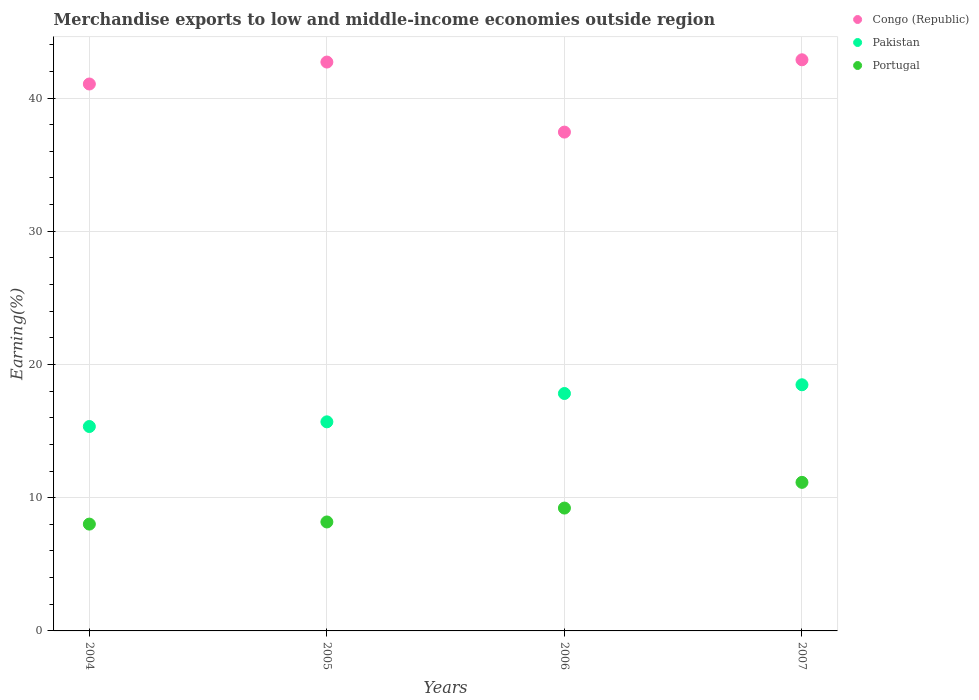How many different coloured dotlines are there?
Offer a terse response. 3. Is the number of dotlines equal to the number of legend labels?
Make the answer very short. Yes. What is the percentage of amount earned from merchandise exports in Portugal in 2007?
Provide a short and direct response. 11.15. Across all years, what is the maximum percentage of amount earned from merchandise exports in Pakistan?
Ensure brevity in your answer.  18.48. Across all years, what is the minimum percentage of amount earned from merchandise exports in Portugal?
Provide a succinct answer. 8.02. In which year was the percentage of amount earned from merchandise exports in Portugal minimum?
Make the answer very short. 2004. What is the total percentage of amount earned from merchandise exports in Portugal in the graph?
Give a very brief answer. 36.57. What is the difference between the percentage of amount earned from merchandise exports in Congo (Republic) in 2005 and that in 2006?
Provide a succinct answer. 5.26. What is the difference between the percentage of amount earned from merchandise exports in Portugal in 2005 and the percentage of amount earned from merchandise exports in Congo (Republic) in 2007?
Ensure brevity in your answer.  -34.69. What is the average percentage of amount earned from merchandise exports in Pakistan per year?
Provide a short and direct response. 16.83. In the year 2005, what is the difference between the percentage of amount earned from merchandise exports in Portugal and percentage of amount earned from merchandise exports in Pakistan?
Your response must be concise. -7.52. What is the ratio of the percentage of amount earned from merchandise exports in Portugal in 2004 to that in 2007?
Make the answer very short. 0.72. Is the percentage of amount earned from merchandise exports in Portugal in 2005 less than that in 2006?
Your answer should be compact. Yes. What is the difference between the highest and the second highest percentage of amount earned from merchandise exports in Congo (Republic)?
Offer a very short reply. 0.17. What is the difference between the highest and the lowest percentage of amount earned from merchandise exports in Congo (Republic)?
Provide a short and direct response. 5.43. In how many years, is the percentage of amount earned from merchandise exports in Portugal greater than the average percentage of amount earned from merchandise exports in Portugal taken over all years?
Your answer should be very brief. 2. Does the percentage of amount earned from merchandise exports in Portugal monotonically increase over the years?
Provide a short and direct response. Yes. How many years are there in the graph?
Make the answer very short. 4. What is the difference between two consecutive major ticks on the Y-axis?
Make the answer very short. 10. Are the values on the major ticks of Y-axis written in scientific E-notation?
Give a very brief answer. No. Does the graph contain any zero values?
Your response must be concise. No. How many legend labels are there?
Make the answer very short. 3. What is the title of the graph?
Your answer should be very brief. Merchandise exports to low and middle-income economies outside region. What is the label or title of the Y-axis?
Provide a short and direct response. Earning(%). What is the Earning(%) of Congo (Republic) in 2004?
Ensure brevity in your answer.  41.05. What is the Earning(%) of Pakistan in 2004?
Make the answer very short. 15.34. What is the Earning(%) of Portugal in 2004?
Keep it short and to the point. 8.02. What is the Earning(%) in Congo (Republic) in 2005?
Your response must be concise. 42.7. What is the Earning(%) of Pakistan in 2005?
Give a very brief answer. 15.69. What is the Earning(%) of Portugal in 2005?
Offer a very short reply. 8.18. What is the Earning(%) in Congo (Republic) in 2006?
Offer a very short reply. 37.44. What is the Earning(%) of Pakistan in 2006?
Keep it short and to the point. 17.82. What is the Earning(%) of Portugal in 2006?
Provide a succinct answer. 9.22. What is the Earning(%) in Congo (Republic) in 2007?
Your answer should be compact. 42.87. What is the Earning(%) in Pakistan in 2007?
Give a very brief answer. 18.48. What is the Earning(%) of Portugal in 2007?
Ensure brevity in your answer.  11.15. Across all years, what is the maximum Earning(%) in Congo (Republic)?
Your response must be concise. 42.87. Across all years, what is the maximum Earning(%) in Pakistan?
Give a very brief answer. 18.48. Across all years, what is the maximum Earning(%) of Portugal?
Provide a short and direct response. 11.15. Across all years, what is the minimum Earning(%) of Congo (Republic)?
Your response must be concise. 37.44. Across all years, what is the minimum Earning(%) in Pakistan?
Provide a short and direct response. 15.34. Across all years, what is the minimum Earning(%) of Portugal?
Offer a very short reply. 8.02. What is the total Earning(%) of Congo (Republic) in the graph?
Offer a very short reply. 164.07. What is the total Earning(%) of Pakistan in the graph?
Your answer should be compact. 67.34. What is the total Earning(%) of Portugal in the graph?
Provide a succinct answer. 36.57. What is the difference between the Earning(%) of Congo (Republic) in 2004 and that in 2005?
Your answer should be compact. -1.65. What is the difference between the Earning(%) in Pakistan in 2004 and that in 2005?
Your answer should be compact. -0.35. What is the difference between the Earning(%) in Portugal in 2004 and that in 2005?
Your response must be concise. -0.16. What is the difference between the Earning(%) of Congo (Republic) in 2004 and that in 2006?
Your response must be concise. 3.61. What is the difference between the Earning(%) of Pakistan in 2004 and that in 2006?
Give a very brief answer. -2.48. What is the difference between the Earning(%) in Portugal in 2004 and that in 2006?
Provide a short and direct response. -1.2. What is the difference between the Earning(%) in Congo (Republic) in 2004 and that in 2007?
Offer a very short reply. -1.82. What is the difference between the Earning(%) in Pakistan in 2004 and that in 2007?
Make the answer very short. -3.13. What is the difference between the Earning(%) of Portugal in 2004 and that in 2007?
Provide a succinct answer. -3.13. What is the difference between the Earning(%) of Congo (Republic) in 2005 and that in 2006?
Keep it short and to the point. 5.26. What is the difference between the Earning(%) of Pakistan in 2005 and that in 2006?
Your answer should be very brief. -2.13. What is the difference between the Earning(%) in Portugal in 2005 and that in 2006?
Your answer should be compact. -1.04. What is the difference between the Earning(%) of Congo (Republic) in 2005 and that in 2007?
Provide a succinct answer. -0.17. What is the difference between the Earning(%) of Pakistan in 2005 and that in 2007?
Your response must be concise. -2.78. What is the difference between the Earning(%) of Portugal in 2005 and that in 2007?
Your answer should be compact. -2.97. What is the difference between the Earning(%) in Congo (Republic) in 2006 and that in 2007?
Ensure brevity in your answer.  -5.43. What is the difference between the Earning(%) in Pakistan in 2006 and that in 2007?
Ensure brevity in your answer.  -0.66. What is the difference between the Earning(%) of Portugal in 2006 and that in 2007?
Your answer should be very brief. -1.93. What is the difference between the Earning(%) in Congo (Republic) in 2004 and the Earning(%) in Pakistan in 2005?
Make the answer very short. 25.36. What is the difference between the Earning(%) of Congo (Republic) in 2004 and the Earning(%) of Portugal in 2005?
Keep it short and to the point. 32.88. What is the difference between the Earning(%) of Pakistan in 2004 and the Earning(%) of Portugal in 2005?
Your response must be concise. 7.17. What is the difference between the Earning(%) in Congo (Republic) in 2004 and the Earning(%) in Pakistan in 2006?
Ensure brevity in your answer.  23.23. What is the difference between the Earning(%) in Congo (Republic) in 2004 and the Earning(%) in Portugal in 2006?
Provide a succinct answer. 31.83. What is the difference between the Earning(%) of Pakistan in 2004 and the Earning(%) of Portugal in 2006?
Your answer should be compact. 6.12. What is the difference between the Earning(%) in Congo (Republic) in 2004 and the Earning(%) in Pakistan in 2007?
Offer a very short reply. 22.58. What is the difference between the Earning(%) in Congo (Republic) in 2004 and the Earning(%) in Portugal in 2007?
Your response must be concise. 29.9. What is the difference between the Earning(%) of Pakistan in 2004 and the Earning(%) of Portugal in 2007?
Give a very brief answer. 4.19. What is the difference between the Earning(%) of Congo (Republic) in 2005 and the Earning(%) of Pakistan in 2006?
Provide a succinct answer. 24.88. What is the difference between the Earning(%) in Congo (Republic) in 2005 and the Earning(%) in Portugal in 2006?
Keep it short and to the point. 33.48. What is the difference between the Earning(%) in Pakistan in 2005 and the Earning(%) in Portugal in 2006?
Provide a short and direct response. 6.47. What is the difference between the Earning(%) of Congo (Republic) in 2005 and the Earning(%) of Pakistan in 2007?
Offer a very short reply. 24.22. What is the difference between the Earning(%) of Congo (Republic) in 2005 and the Earning(%) of Portugal in 2007?
Give a very brief answer. 31.55. What is the difference between the Earning(%) in Pakistan in 2005 and the Earning(%) in Portugal in 2007?
Give a very brief answer. 4.54. What is the difference between the Earning(%) in Congo (Republic) in 2006 and the Earning(%) in Pakistan in 2007?
Your response must be concise. 18.97. What is the difference between the Earning(%) in Congo (Republic) in 2006 and the Earning(%) in Portugal in 2007?
Give a very brief answer. 26.29. What is the difference between the Earning(%) in Pakistan in 2006 and the Earning(%) in Portugal in 2007?
Your answer should be compact. 6.67. What is the average Earning(%) in Congo (Republic) per year?
Offer a very short reply. 41.02. What is the average Earning(%) of Pakistan per year?
Provide a short and direct response. 16.83. What is the average Earning(%) of Portugal per year?
Give a very brief answer. 9.14. In the year 2004, what is the difference between the Earning(%) in Congo (Republic) and Earning(%) in Pakistan?
Offer a very short reply. 25.71. In the year 2004, what is the difference between the Earning(%) in Congo (Republic) and Earning(%) in Portugal?
Give a very brief answer. 33.04. In the year 2004, what is the difference between the Earning(%) in Pakistan and Earning(%) in Portugal?
Your answer should be very brief. 7.33. In the year 2005, what is the difference between the Earning(%) in Congo (Republic) and Earning(%) in Pakistan?
Offer a very short reply. 27.01. In the year 2005, what is the difference between the Earning(%) in Congo (Republic) and Earning(%) in Portugal?
Offer a terse response. 34.52. In the year 2005, what is the difference between the Earning(%) of Pakistan and Earning(%) of Portugal?
Your answer should be very brief. 7.52. In the year 2006, what is the difference between the Earning(%) of Congo (Republic) and Earning(%) of Pakistan?
Provide a short and direct response. 19.62. In the year 2006, what is the difference between the Earning(%) of Congo (Republic) and Earning(%) of Portugal?
Ensure brevity in your answer.  28.22. In the year 2006, what is the difference between the Earning(%) in Pakistan and Earning(%) in Portugal?
Your answer should be compact. 8.6. In the year 2007, what is the difference between the Earning(%) of Congo (Republic) and Earning(%) of Pakistan?
Your answer should be compact. 24.39. In the year 2007, what is the difference between the Earning(%) of Congo (Republic) and Earning(%) of Portugal?
Provide a succinct answer. 31.72. In the year 2007, what is the difference between the Earning(%) in Pakistan and Earning(%) in Portugal?
Provide a succinct answer. 7.33. What is the ratio of the Earning(%) of Congo (Republic) in 2004 to that in 2005?
Keep it short and to the point. 0.96. What is the ratio of the Earning(%) in Pakistan in 2004 to that in 2005?
Ensure brevity in your answer.  0.98. What is the ratio of the Earning(%) of Portugal in 2004 to that in 2005?
Give a very brief answer. 0.98. What is the ratio of the Earning(%) in Congo (Republic) in 2004 to that in 2006?
Make the answer very short. 1.1. What is the ratio of the Earning(%) in Pakistan in 2004 to that in 2006?
Your response must be concise. 0.86. What is the ratio of the Earning(%) of Portugal in 2004 to that in 2006?
Keep it short and to the point. 0.87. What is the ratio of the Earning(%) in Congo (Republic) in 2004 to that in 2007?
Offer a terse response. 0.96. What is the ratio of the Earning(%) of Pakistan in 2004 to that in 2007?
Ensure brevity in your answer.  0.83. What is the ratio of the Earning(%) in Portugal in 2004 to that in 2007?
Make the answer very short. 0.72. What is the ratio of the Earning(%) of Congo (Republic) in 2005 to that in 2006?
Ensure brevity in your answer.  1.14. What is the ratio of the Earning(%) in Pakistan in 2005 to that in 2006?
Offer a very short reply. 0.88. What is the ratio of the Earning(%) in Portugal in 2005 to that in 2006?
Make the answer very short. 0.89. What is the ratio of the Earning(%) in Congo (Republic) in 2005 to that in 2007?
Keep it short and to the point. 1. What is the ratio of the Earning(%) in Pakistan in 2005 to that in 2007?
Ensure brevity in your answer.  0.85. What is the ratio of the Earning(%) in Portugal in 2005 to that in 2007?
Provide a succinct answer. 0.73. What is the ratio of the Earning(%) in Congo (Republic) in 2006 to that in 2007?
Give a very brief answer. 0.87. What is the ratio of the Earning(%) of Pakistan in 2006 to that in 2007?
Provide a short and direct response. 0.96. What is the ratio of the Earning(%) in Portugal in 2006 to that in 2007?
Offer a terse response. 0.83. What is the difference between the highest and the second highest Earning(%) of Congo (Republic)?
Provide a short and direct response. 0.17. What is the difference between the highest and the second highest Earning(%) of Pakistan?
Provide a short and direct response. 0.66. What is the difference between the highest and the second highest Earning(%) in Portugal?
Your answer should be compact. 1.93. What is the difference between the highest and the lowest Earning(%) of Congo (Republic)?
Ensure brevity in your answer.  5.43. What is the difference between the highest and the lowest Earning(%) in Pakistan?
Provide a succinct answer. 3.13. What is the difference between the highest and the lowest Earning(%) of Portugal?
Offer a terse response. 3.13. 